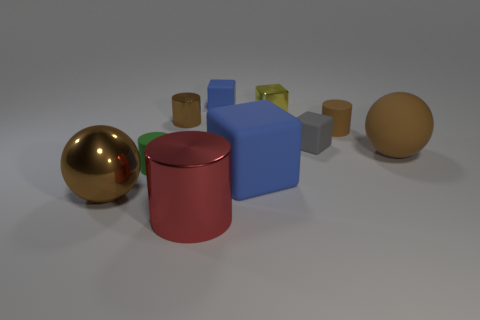There is a brown ball that is made of the same material as the green object; what is its size?
Offer a terse response. Large. There is a blue object that is on the left side of the blue thing in front of the small brown cylinder to the left of the gray thing; how big is it?
Give a very brief answer. Small. There is a blue cube that is in front of the tiny yellow thing; what size is it?
Provide a short and direct response. Large. How many yellow things are either rubber balls or shiny objects?
Offer a terse response. 1. Are there any gray rubber cylinders of the same size as the gray cube?
Make the answer very short. No. What is the material of the yellow object that is the same size as the gray block?
Your response must be concise. Metal. Is the size of the metallic thing in front of the big brown shiny sphere the same as the block that is on the left side of the big blue matte thing?
Provide a succinct answer. No. What number of things are blocks or shiny objects left of the big red metallic object?
Give a very brief answer. 6. Are there any big red shiny things that have the same shape as the small green thing?
Keep it short and to the point. Yes. What size is the matte cube that is in front of the rubber block right of the yellow thing?
Make the answer very short. Large. 